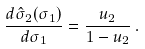<formula> <loc_0><loc_0><loc_500><loc_500>\frac { d \hat { \sigma } _ { 2 } ( \sigma _ { 1 } ) } { d \sigma _ { 1 } } = \frac { u _ { 2 } } { 1 - u _ { 2 } } \, .</formula> 